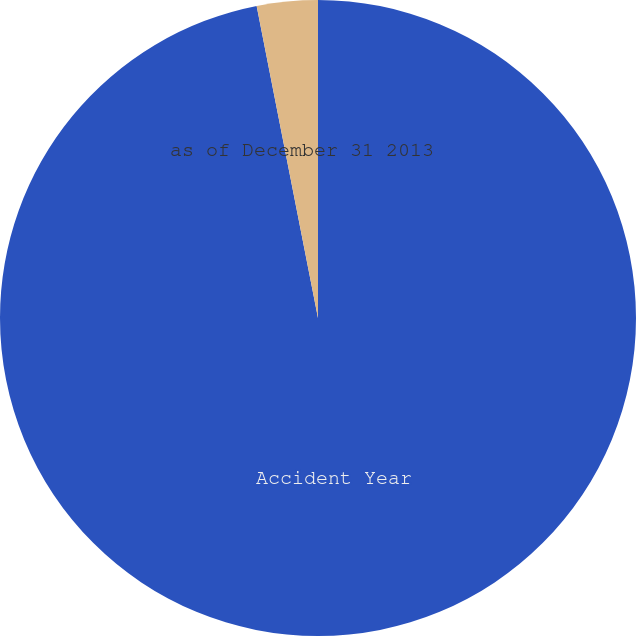<chart> <loc_0><loc_0><loc_500><loc_500><pie_chart><fcel>Accident Year<fcel>as of December 31 2013<nl><fcel>96.91%<fcel>3.09%<nl></chart> 